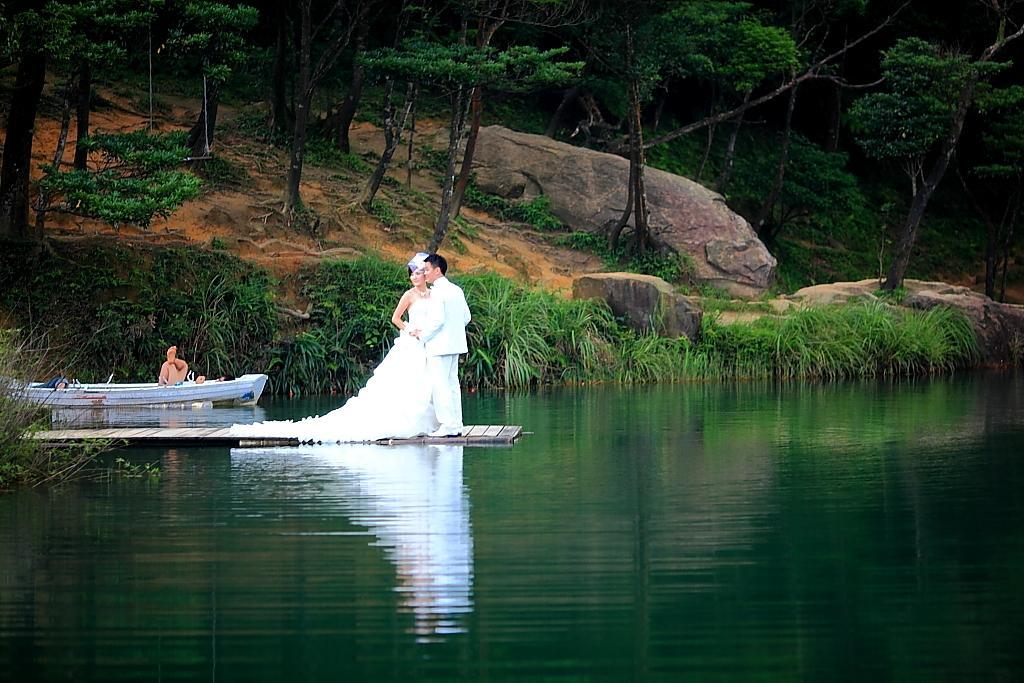In one or two sentences, can you explain what this image depicts? In this image we can see a couple standing on the wooden path, there are some plants, grass, trees, also we can see the lake. 